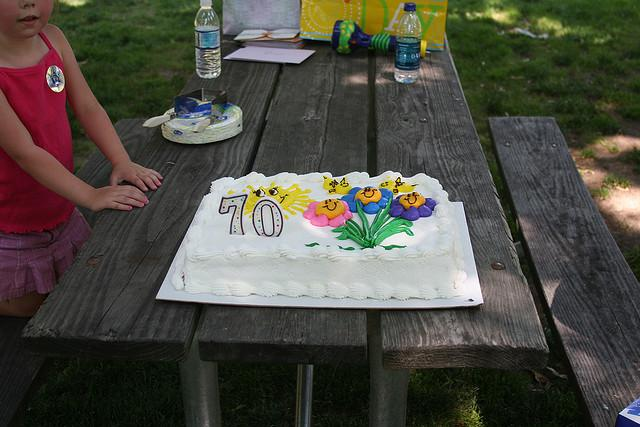What item is drawn on the cake? Please explain your reasoning. sun. It is yellow with rays extending towards the flowers next to it. 